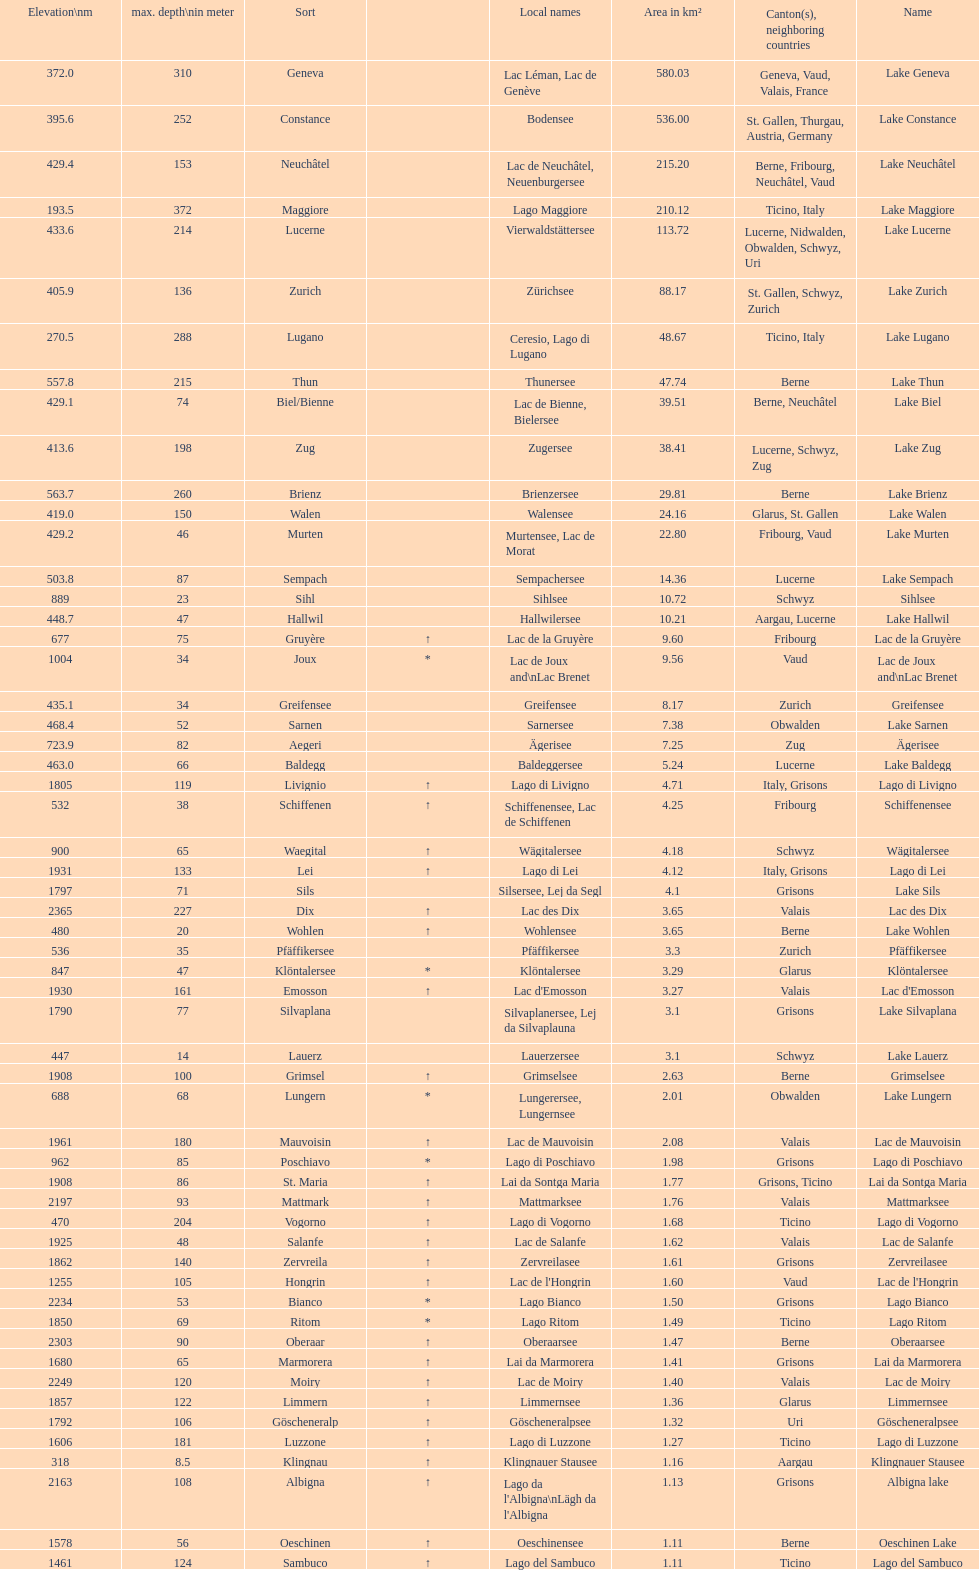Which lake has the deepest max depth? Lake Maggiore. 